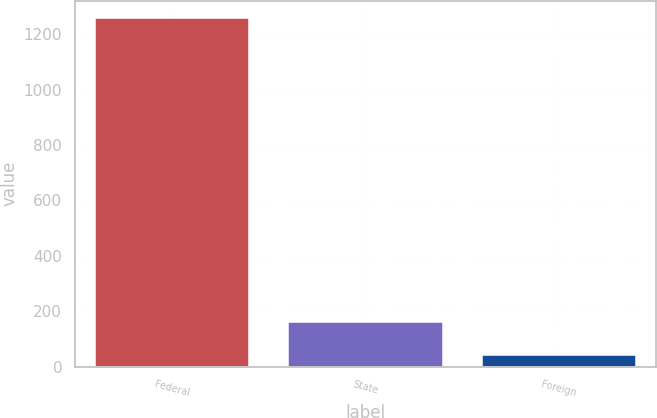Convert chart. <chart><loc_0><loc_0><loc_500><loc_500><bar_chart><fcel>Federal<fcel>State<fcel>Foreign<nl><fcel>1259<fcel>161.9<fcel>40<nl></chart> 